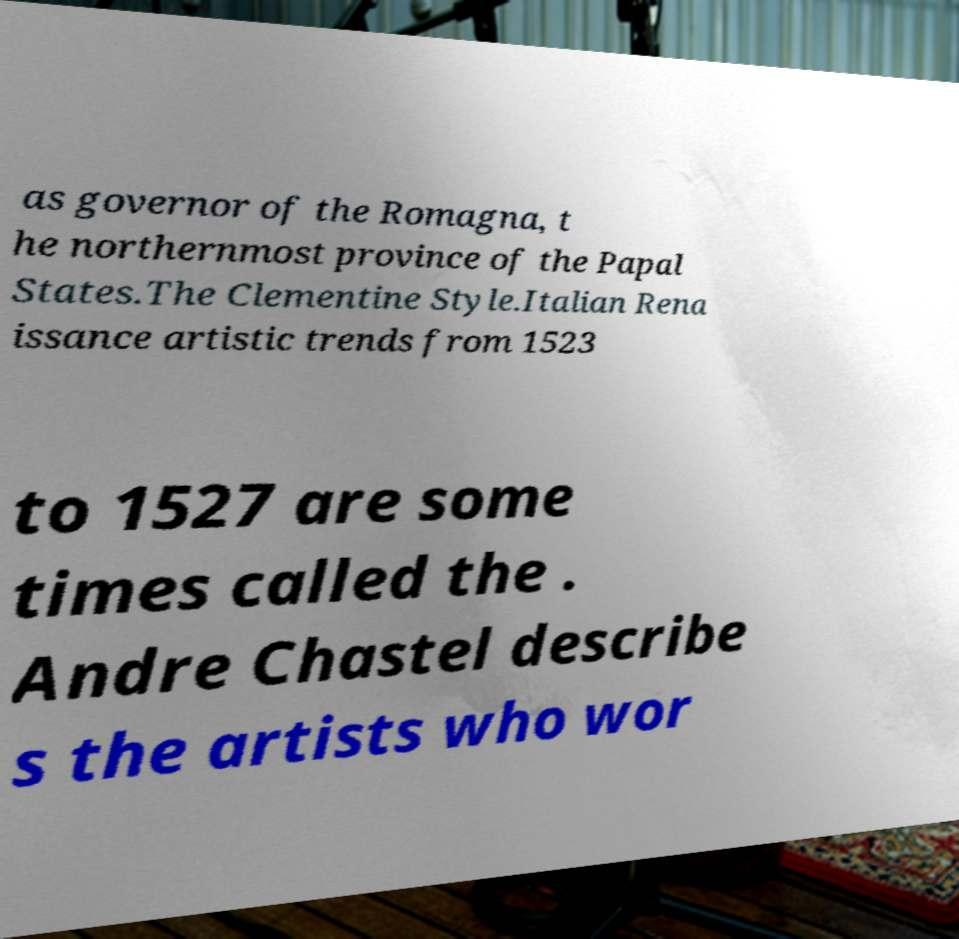Could you assist in decoding the text presented in this image and type it out clearly? as governor of the Romagna, t he northernmost province of the Papal States.The Clementine Style.Italian Rena issance artistic trends from 1523 to 1527 are some times called the . Andre Chastel describe s the artists who wor 